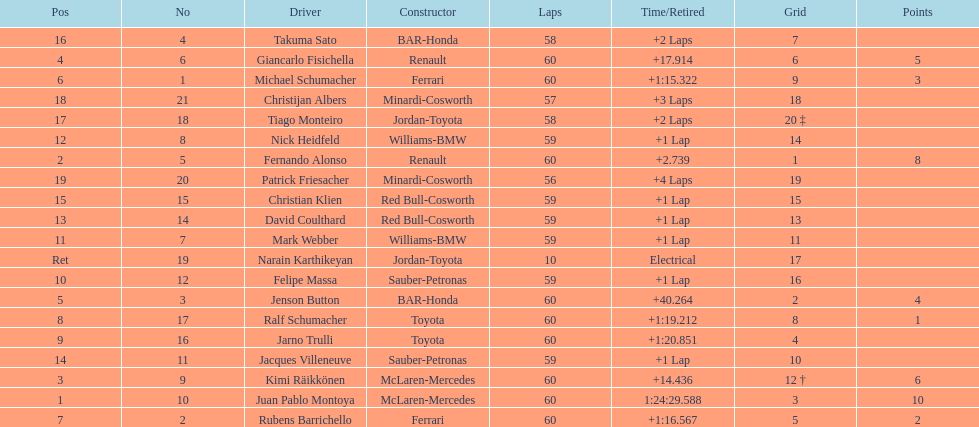What is the number of drivers who earned points in the race? 8. Could you parse the entire table as a dict? {'header': ['Pos', 'No', 'Driver', 'Constructor', 'Laps', 'Time/Retired', 'Grid', 'Points'], 'rows': [['16', '4', 'Takuma Sato', 'BAR-Honda', '58', '+2 Laps', '7', ''], ['4', '6', 'Giancarlo Fisichella', 'Renault', '60', '+17.914', '6', '5'], ['6', '1', 'Michael Schumacher', 'Ferrari', '60', '+1:15.322', '9', '3'], ['18', '21', 'Christijan Albers', 'Minardi-Cosworth', '57', '+3 Laps', '18', ''], ['17', '18', 'Tiago Monteiro', 'Jordan-Toyota', '58', '+2 Laps', '20 ‡', ''], ['12', '8', 'Nick Heidfeld', 'Williams-BMW', '59', '+1 Lap', '14', ''], ['2', '5', 'Fernando Alonso', 'Renault', '60', '+2.739', '1', '8'], ['19', '20', 'Patrick Friesacher', 'Minardi-Cosworth', '56', '+4 Laps', '19', ''], ['15', '15', 'Christian Klien', 'Red Bull-Cosworth', '59', '+1 Lap', '15', ''], ['13', '14', 'David Coulthard', 'Red Bull-Cosworth', '59', '+1 Lap', '13', ''], ['11', '7', 'Mark Webber', 'Williams-BMW', '59', '+1 Lap', '11', ''], ['Ret', '19', 'Narain Karthikeyan', 'Jordan-Toyota', '10', 'Electrical', '17', ''], ['10', '12', 'Felipe Massa', 'Sauber-Petronas', '59', '+1 Lap', '16', ''], ['5', '3', 'Jenson Button', 'BAR-Honda', '60', '+40.264', '2', '4'], ['8', '17', 'Ralf Schumacher', 'Toyota', '60', '+1:19.212', '8', '1'], ['9', '16', 'Jarno Trulli', 'Toyota', '60', '+1:20.851', '4', ''], ['14', '11', 'Jacques Villeneuve', 'Sauber-Petronas', '59', '+1 Lap', '10', ''], ['3', '9', 'Kimi Räikkönen', 'McLaren-Mercedes', '60', '+14.436', '12 †', '6'], ['1', '10', 'Juan Pablo Montoya', 'McLaren-Mercedes', '60', '1:24:29.588', '3', '10'], ['7', '2', 'Rubens Barrichello', 'Ferrari', '60', '+1:16.567', '5', '2']]} 